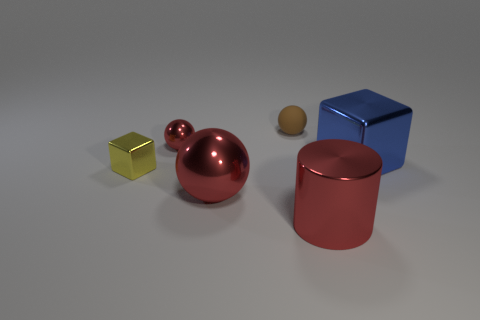Add 2 purple rubber spheres. How many objects exist? 8 Subtract all cylinders. How many objects are left? 5 Add 2 large red shiny cylinders. How many large red shiny cylinders are left? 3 Add 3 large blue objects. How many large blue objects exist? 4 Subtract 0 green blocks. How many objects are left? 6 Subtract all big red things. Subtract all yellow shiny cylinders. How many objects are left? 4 